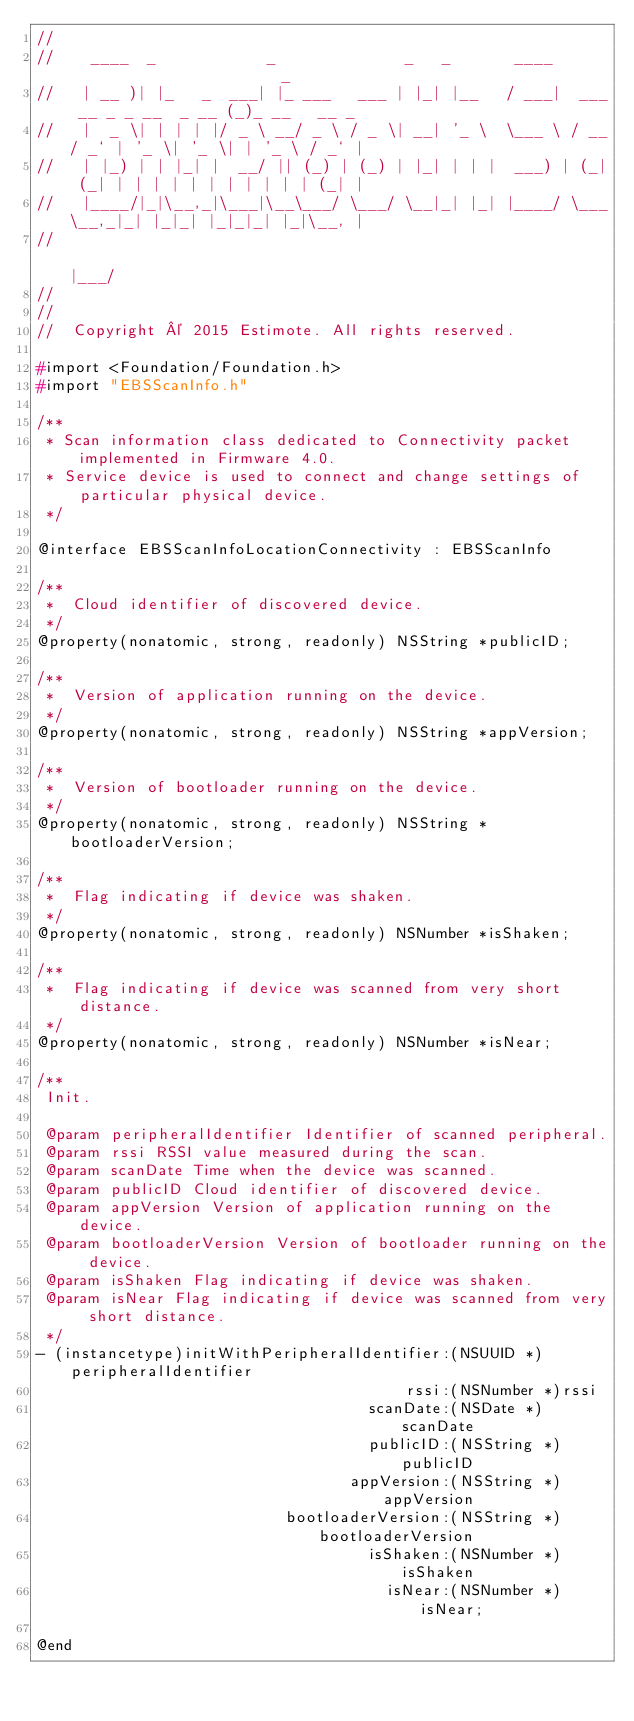<code> <loc_0><loc_0><loc_500><loc_500><_C_>//
//    ____  _            _              _   _       ____                        _
//   | __ )| |_   _  ___| |_ ___   ___ | |_| |__   / ___|  ___ __ _ _ __  _ __ (_)_ __   __ _
//   |  _ \| | | | |/ _ \ __/ _ \ / _ \| __| '_ \  \___ \ / __/ _` | '_ \| '_ \| | '_ \ / _` |
//   | |_) | | |_| |  __/ || (_) | (_) | |_| | | |  ___) | (_| (_| | | | | | | | | | | | (_| |
//   |____/|_|\__,_|\___|\__\___/ \___/ \__|_| |_| |____/ \___\__,_|_| |_|_| |_|_|_| |_|\__, |
//                                                                                      |___/
//
//
//  Copyright © 2015 Estimote. All rights reserved.

#import <Foundation/Foundation.h>
#import "EBSScanInfo.h"

/**
 * Scan information class dedicated to Connectivity packet implemented in Firmware 4.0.
 * Service device is used to connect and change settings of particular physical device.
 */

@interface EBSScanInfoLocationConnectivity : EBSScanInfo

/**
 *  Cloud identifier of discovered device.
 */
@property(nonatomic, strong, readonly) NSString *publicID;

/**
 *  Version of application running on the device.
 */
@property(nonatomic, strong, readonly) NSString *appVersion;

/**
 *  Version of bootloader running on the device.
 */
@property(nonatomic, strong, readonly) NSString *bootloaderVersion;

/**
 *  Flag indicating if device was shaken.
 */
@property(nonatomic, strong, readonly) NSNumber *isShaken;

/**
 *  Flag indicating if device was scanned from very short distance.
 */
@property(nonatomic, strong, readonly) NSNumber *isNear;

/**
 Init.

 @param peripheralIdentifier Identifier of scanned peripheral.
 @param rssi RSSI value measured during the scan.
 @param scanDate Time when the device was scanned.
 @param publicID Cloud identifier of discovered device.
 @param appVersion Version of application running on the device.
 @param bootloaderVersion Version of bootloader running on the device.
 @param isShaken Flag indicating if device was shaken.
 @param isNear Flag indicating if device was scanned from very short distance.
 */
- (instancetype)initWithPeripheralIdentifier:(NSUUID *)peripheralIdentifier
                                        rssi:(NSNumber *)rssi
                                    scanDate:(NSDate *)scanDate
                                    publicID:(NSString *)publicID
                                  appVersion:(NSString *)appVersion
                           bootloaderVersion:(NSString *)bootloaderVersion
                                    isShaken:(NSNumber *)isShaken
                                      isNear:(NSNumber *)isNear;

@end
</code> 